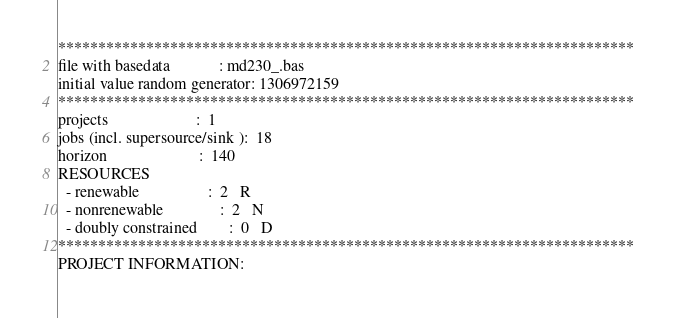Convert code to text. <code><loc_0><loc_0><loc_500><loc_500><_ObjectiveC_>************************************************************************
file with basedata            : md230_.bas
initial value random generator: 1306972159
************************************************************************
projects                      :  1
jobs (incl. supersource/sink ):  18
horizon                       :  140
RESOURCES
  - renewable                 :  2   R
  - nonrenewable              :  2   N
  - doubly constrained        :  0   D
************************************************************************
PROJECT INFORMATION:</code> 